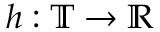<formula> <loc_0><loc_0><loc_500><loc_500>h \colon \mathbb { T } \to \mathbb { R }</formula> 